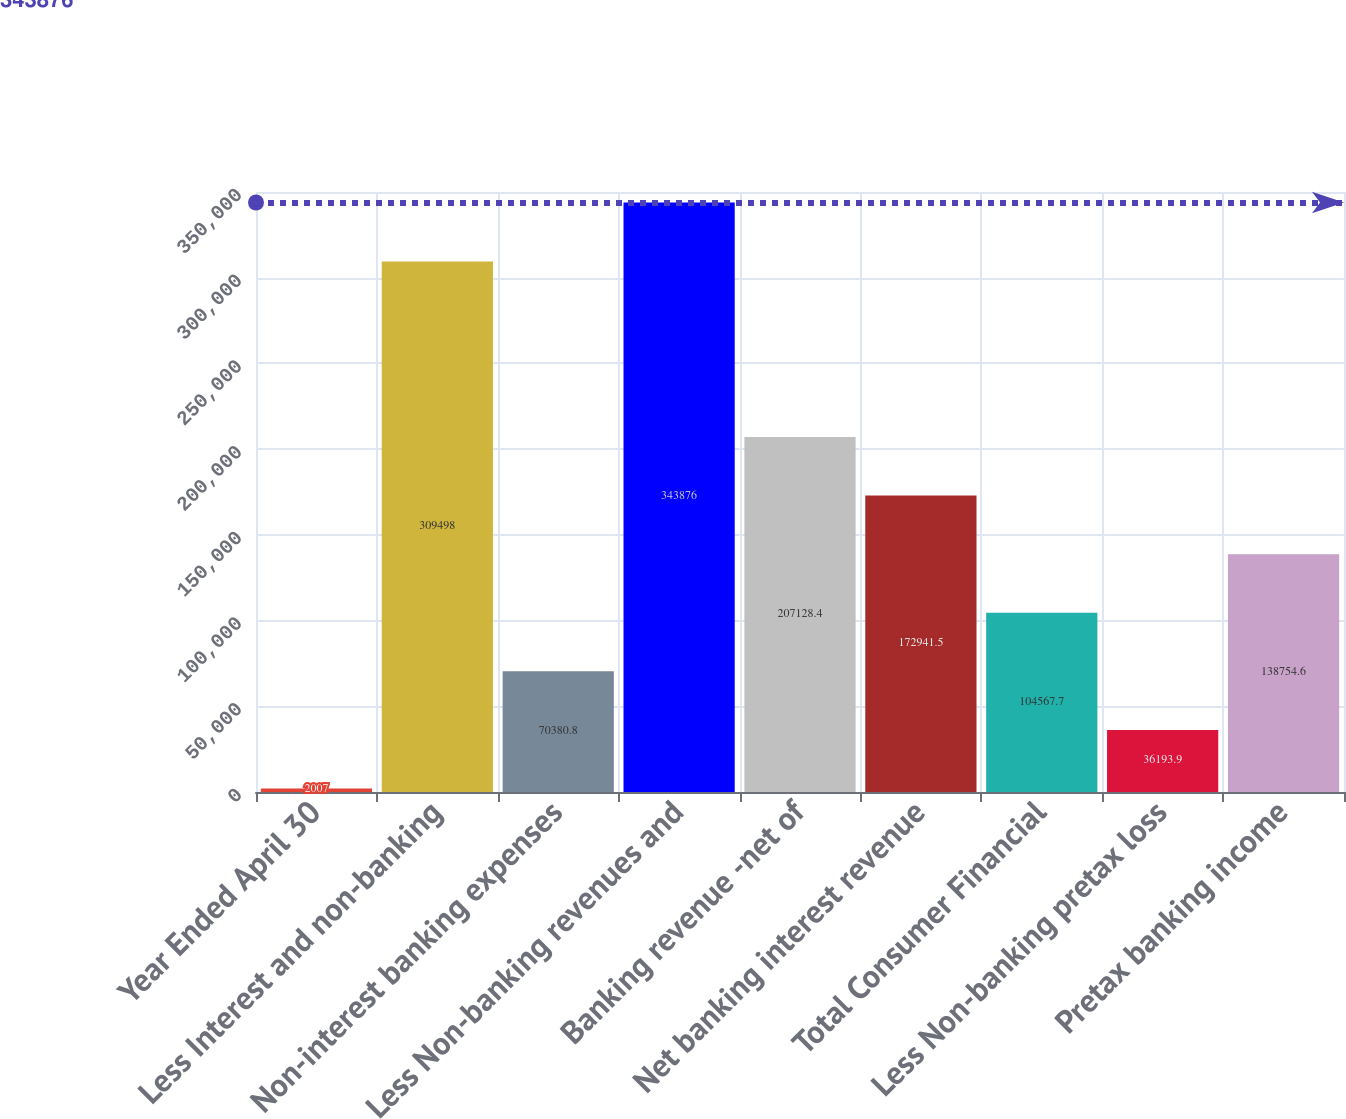Convert chart to OTSL. <chart><loc_0><loc_0><loc_500><loc_500><bar_chart><fcel>Year Ended April 30<fcel>Less Interest and non-banking<fcel>Non-interest banking expenses<fcel>Less Non-banking revenues and<fcel>Banking revenue -net of<fcel>Net banking interest revenue<fcel>Total Consumer Financial<fcel>Less Non-banking pretax loss<fcel>Pretax banking income<nl><fcel>2007<fcel>309498<fcel>70380.8<fcel>343876<fcel>207128<fcel>172942<fcel>104568<fcel>36193.9<fcel>138755<nl></chart> 